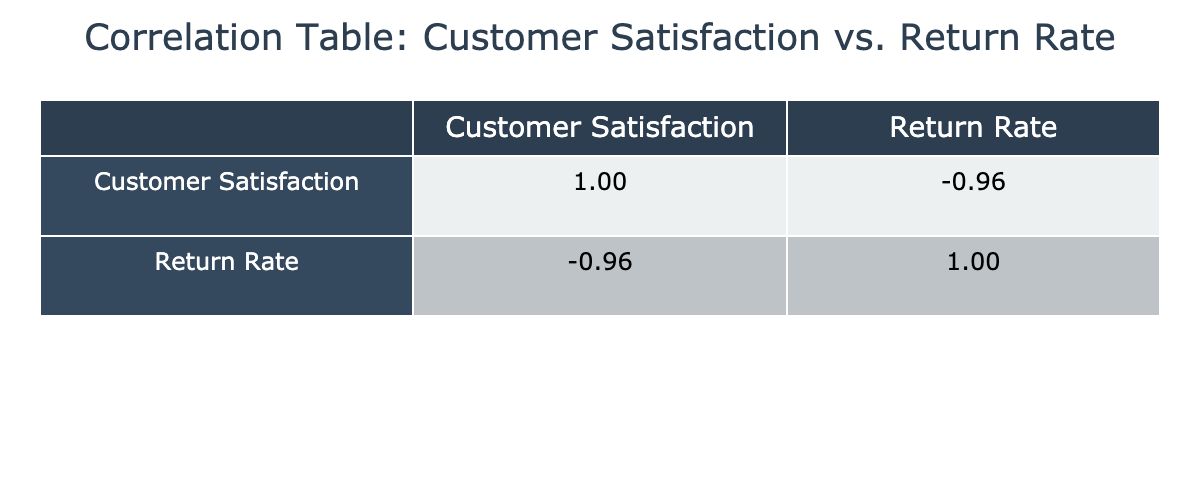What is the correlation coefficient between Customer Satisfaction and Return Rate? Looking at the correlation table, the value representing the correlation between Customer Satisfaction Score and Return Rate is -0.87. This indicates a strong negative correlation.
Answer: -0.87 Which Customer Satisfaction Score corresponds to the lowest Return Rate? The lowest Return Rate is 1, which corresponds to a Customer Satisfaction Score of 95 (CUST008).
Answer: 95 What is the average Customer Satisfaction Score for customers with a Return Rate higher than 15%? The customers with a Return Rate higher than 15% (CUST004, CUST005, CUST015) have scores of 60, 74, and 62, respectively. Summing these values gives 196, and dividing by 3 gives an average of 65.33.
Answer: 65.33 Is there a Customer with a Return Rate below 5%? From the table, the lowest Return Rate is 1%, indicating that CUST008 has a Return Rate below 5%.
Answer: Yes What is the difference in Return Rates between the highest and the lowest Customer Satisfaction Scores? The highest Customer Satisfaction Score is 95 (CUST008) with a Return Rate of 1%, and the lowest Customer Satisfaction Score is 60 (CUST004) with a Return Rate of 20%. The difference is 20 - 1 = 19.
Answer: 19 Which Customer Satisfaction Score has the highest Return Rate, and what is that Rate? The highest Return Rate is 22%, which corresponds to a Customer Satisfaction Score of 62 (CUST015).
Answer: 62, 22% Calculate the median Customer Satisfaction Score for customers with Return Rates less than 10%. The customers with Return Rates less than 10% are CUST003 (92), CUST006 (88), CUST011 (89), CUST013 (91), CUST001 (85), and CUST020 (82). Arranging these scores, we have [82, 85, 88, 89, 91, 92]. The median is the average of the two center values (88 + 89)/2 = 88.5.
Answer: 88.5 How many customers have a Customer Satisfaction Score of 80 or higher? The customers with a Customer Satisfaction Score of 80 or higher are CUST001, CUST003, CUST006, CUST007, CUST008, CUST011, CUST013, CUST016, CUST017, and CUST020, totaling 10 customers.
Answer: 10 Is the correlation between Customer Satisfaction Score and Return Rates positive? The correlation coefficient is -0.87, which indicates a strong negative correlation. Therefore, it is not positive.
Answer: No 